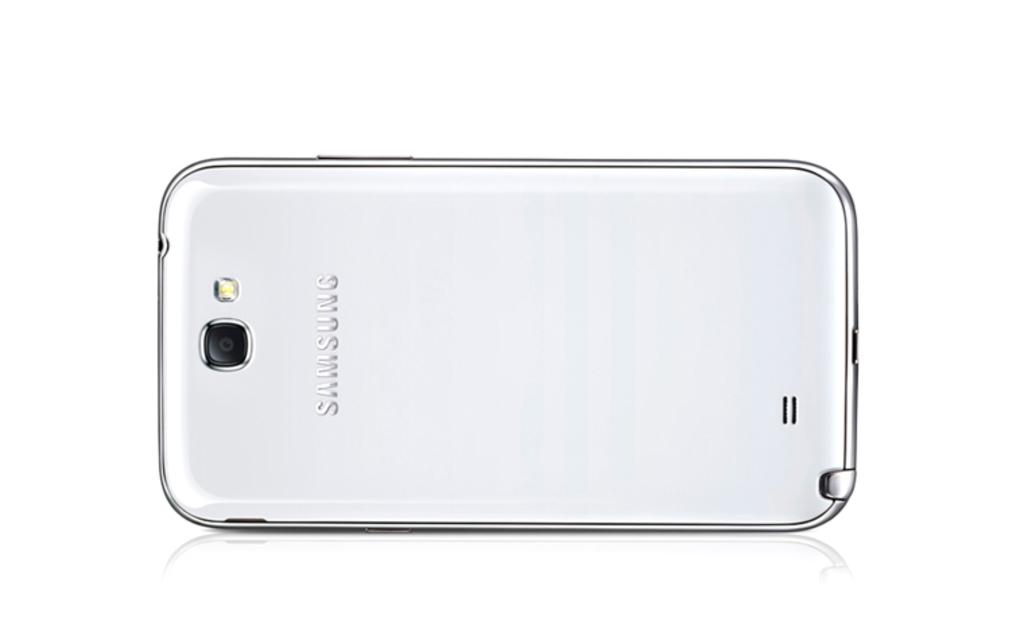What is the brand of this phone?
Give a very brief answer. Samsung. 